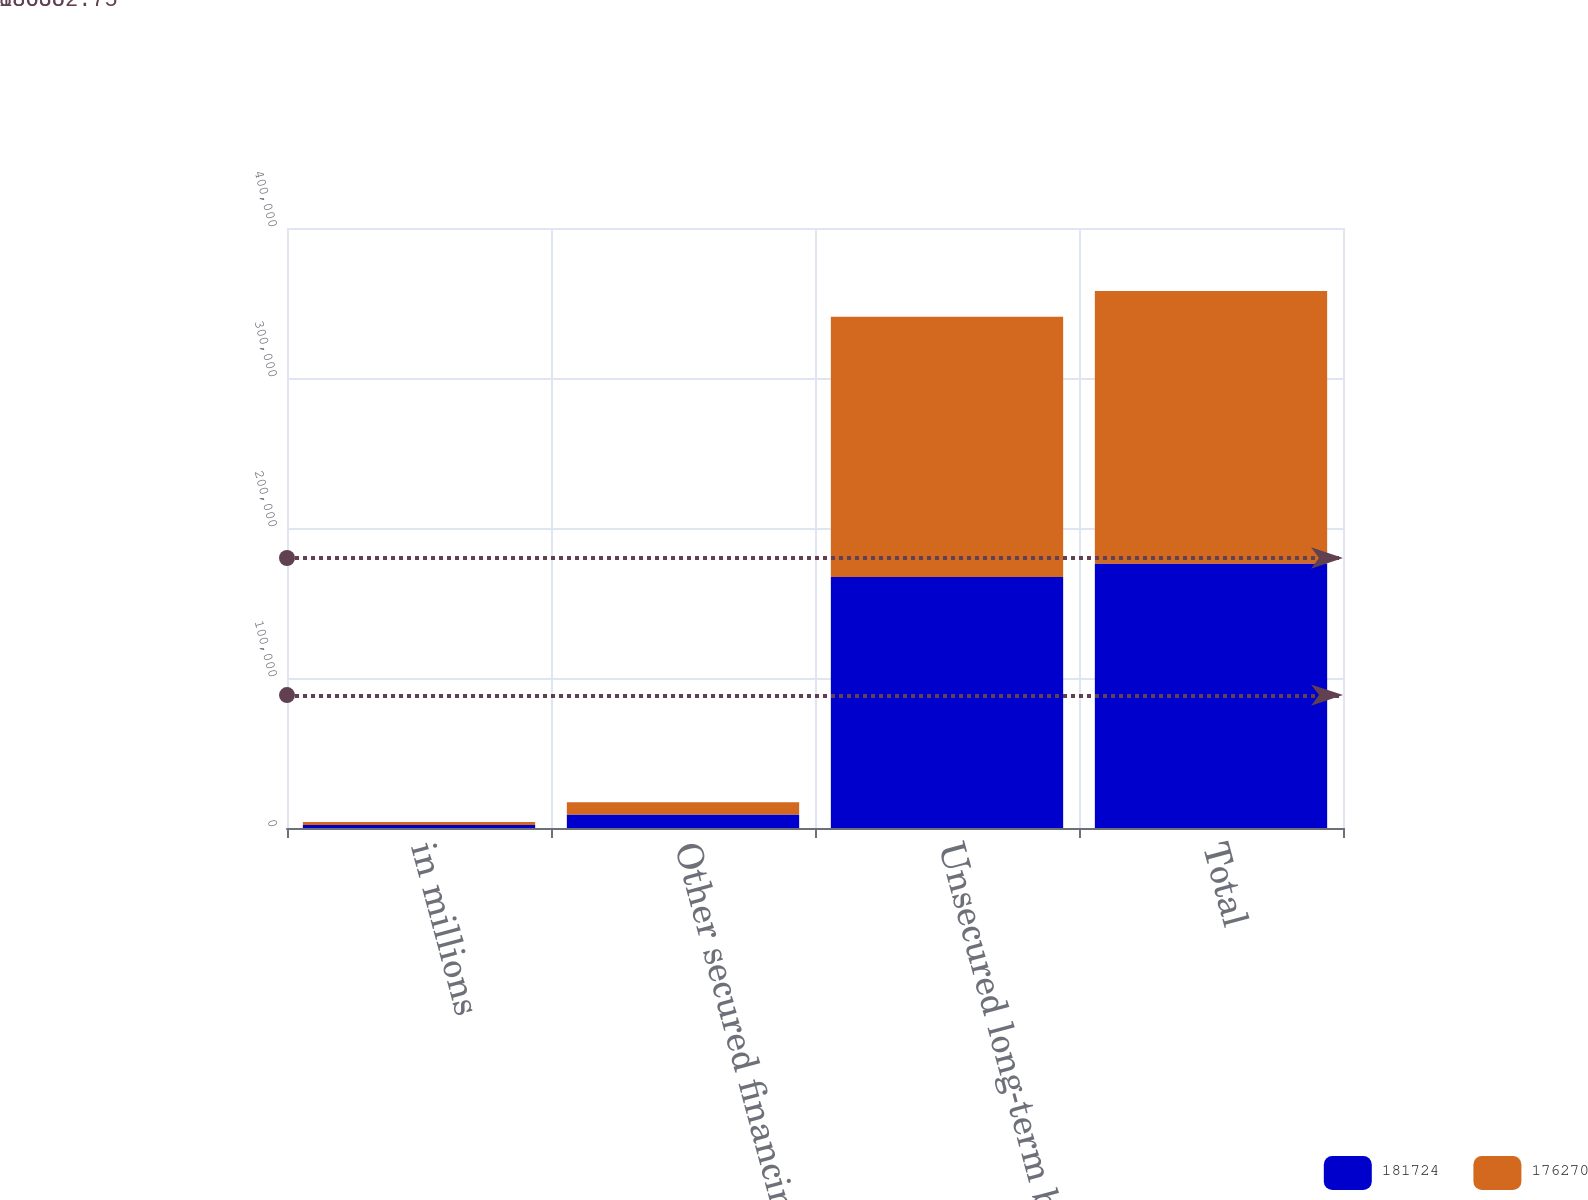<chart> <loc_0><loc_0><loc_500><loc_500><stacked_bar_chart><ecel><fcel>in millions<fcel>Other secured financings<fcel>Unsecured long-term borrowings<fcel>Total<nl><fcel>181724<fcel>2012<fcel>8965<fcel>167305<fcel>176270<nl><fcel>176270<fcel>2011<fcel>8179<fcel>173545<fcel>181724<nl></chart> 